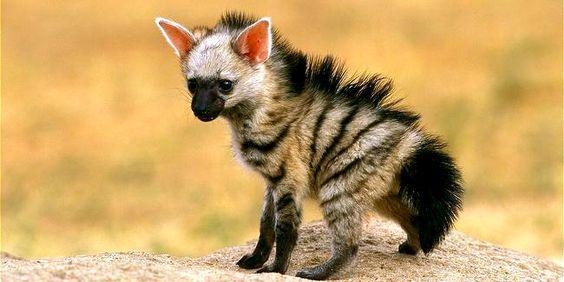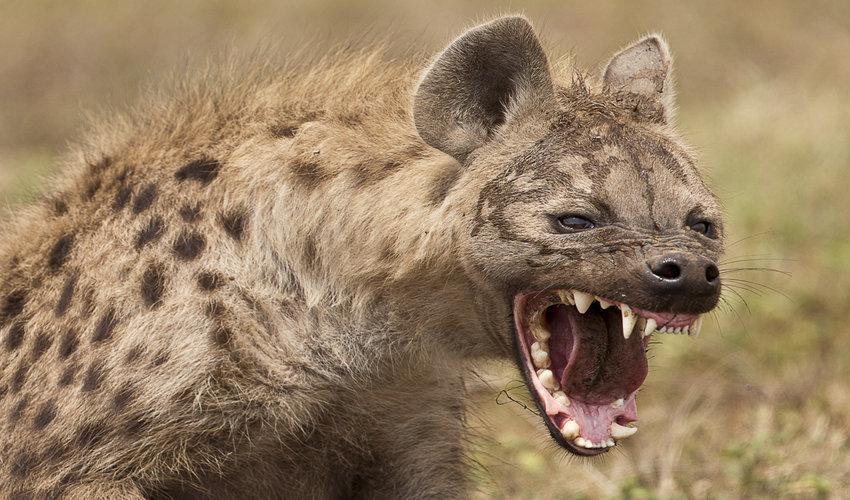The first image is the image on the left, the second image is the image on the right. Examine the images to the left and right. Is the description "One image shows a hyena baring its fangs in a wide-opened mouth." accurate? Answer yes or no. Yes. The first image is the image on the left, the second image is the image on the right. Assess this claim about the two images: "A hyena has its mouth wide open with sharp teeth visible.". Correct or not? Answer yes or no. Yes. 